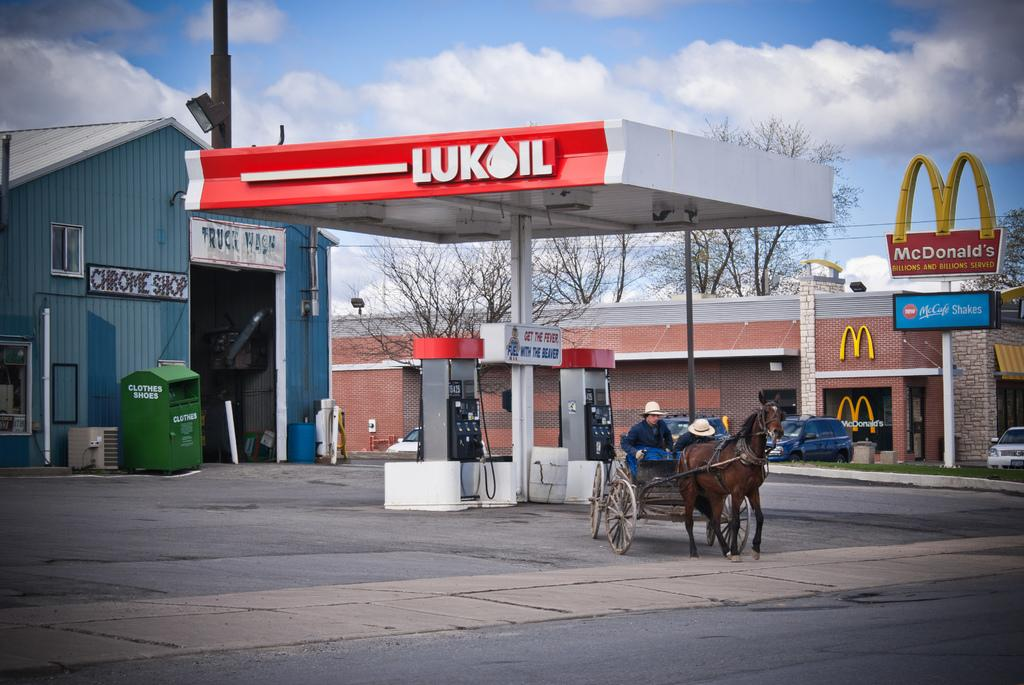What type of establishment is shown in the image? There is a gas station in the image. What mode of transportation is present at the gas station? There is a horse cart at the gas station. How many people are in the horse cart? There are two men sitting in the horse cart. What can be seen in the background of the image? There is a McDonald's and trees in the background of the image. What type of battle is taking place in the image? There is no battle present in the image; it features a gas station, a horse cart, and a McDonald's. How many leaves can be seen on the trees in the image? The number of leaves on the trees cannot be determined from the image, as the focus is on the gas station, horse cart, and McDonald's. 